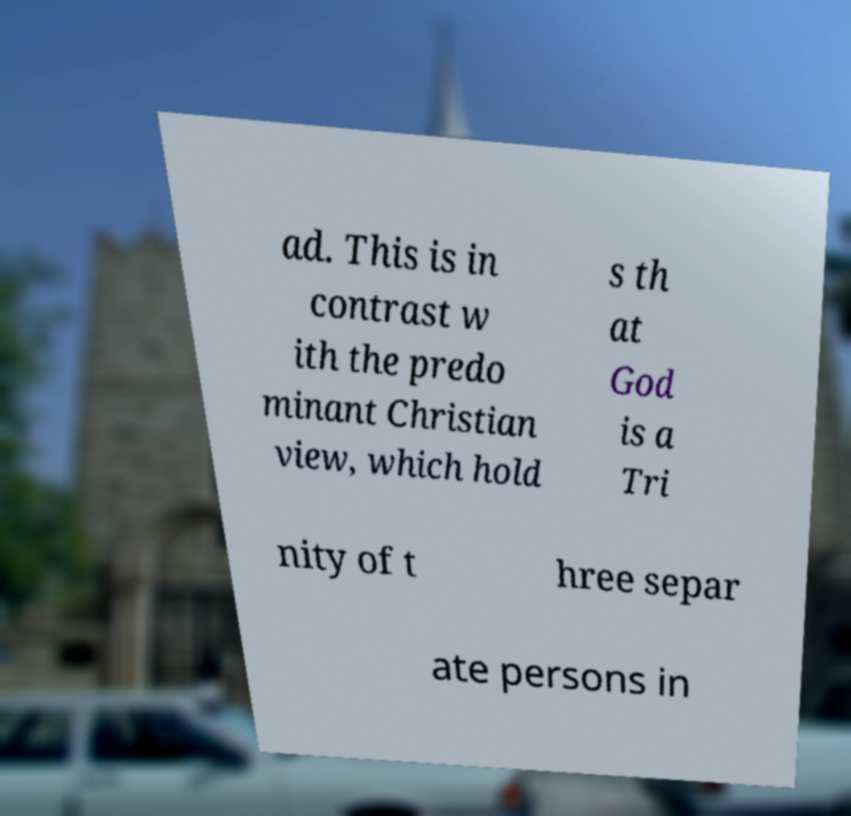Can you read and provide the text displayed in the image?This photo seems to have some interesting text. Can you extract and type it out for me? ad. This is in contrast w ith the predo minant Christian view, which hold s th at God is a Tri nity of t hree separ ate persons in 